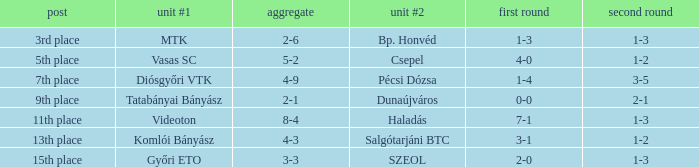What is the 2nd leg of the 4-9 agg.? 3-5. 